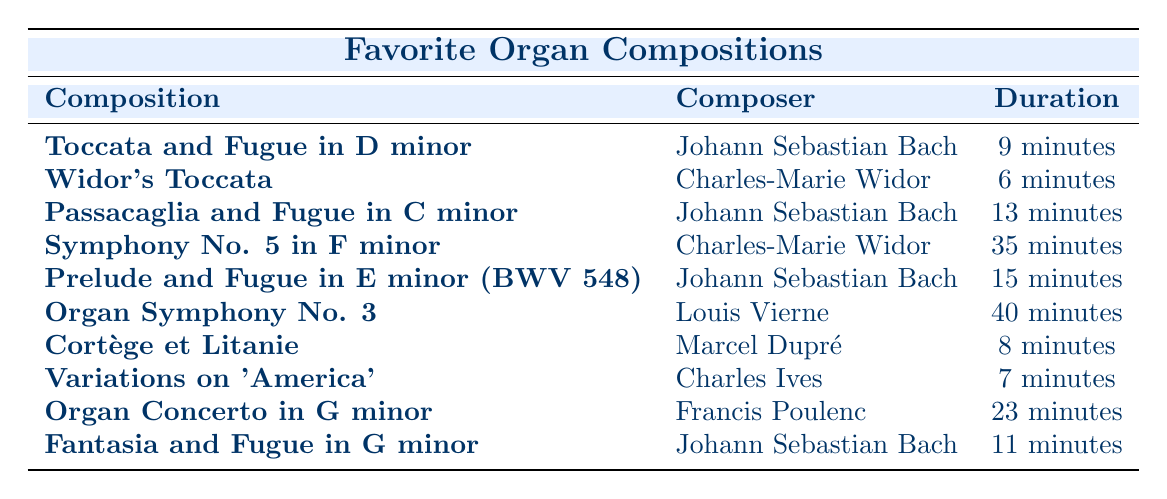What is the duration of "Widor's Toccata"? By looking at the table, we see that "Widor's Toccata" has a listed duration of "6 minutes."
Answer: 6 minutes Which composer has the longest organ composition listed? In the table, we check the "Duration" column for all compositions. The "Organ Symphony No. 3" by Louis Vierne has the longest duration of "40 minutes."
Answer: Louis Vierne How many compositions by Johann Sebastian Bach are there? We need to count the number of rows in the table where the composer is "Johann Sebastian Bach." We find there are four compositions by him: "Toccata and Fugue in D minor," "Passacaglia and Fugue in C minor," "Prelude and Fugue in E minor (BWV 548)," and "Fantasia and Fugue in G minor."
Answer: 4 What is the average duration of the compositions by Charles-Marie Widor? To calculate the average, we need the durations of Widor's compositions: "Widor's Toccata" (6 minutes) and "Symphony No. 5 in F minor" (35 minutes). The total duration is 6 + 35 = 41 minutes, and there are 2 compositions, so the average is 41/2 = 20.5 minutes.
Answer: 20.5 minutes Is "Cortège et Litanie" longer than "Variations on 'America'"? Looking at the durations, "Cortège et Litanie" is "8 minutes" and "Variations on 'America'" is "7 minutes." Since 8 minutes is greater than 7 minutes, the statement is true.
Answer: Yes 